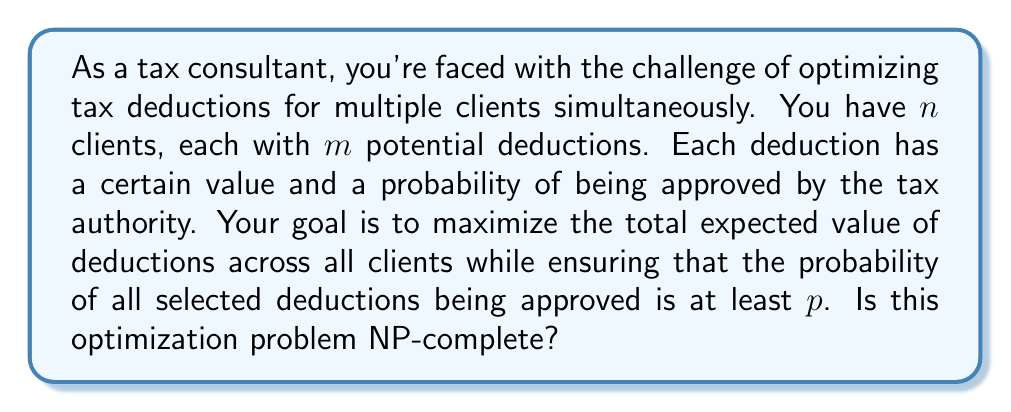What is the answer to this math problem? To determine if this problem is NP-complete, we need to show that it is both in NP and NP-hard.

1. The problem is in NP:
   A solution can be verified in polynomial time by calculating the total expected value of the selected deductions and checking if the probability of all being approved is at least $p$.

2. To prove NP-hardness, we can reduce a known NP-complete problem to this one. Let's reduce the 0-1 Knapsack problem to our tax deduction optimization problem.

   Reduction from 0-1 Knapsack:
   - For each item in the Knapsack problem, create a client with one deduction.
   - Set the value of each deduction to the value of the corresponding Knapsack item.
   - Set the weight of each Knapsack item as $w_i = -\log(p_i)$, where $p_i$ is the probability of the deduction being approved.
   - Set the Knapsack capacity $W = -\log(p)$, where $p$ is the minimum probability of all deductions being approved.

   This reduction preserves the structure of the problem:
   $$\prod_{i=1}^n p_i \geq p \iff \sum_{i=1}^n -\log(p_i) \leq -\log(p)$$

   The reduction is polynomial-time computable, and a solution to the tax deduction problem would solve the 0-1 Knapsack problem.

3. The decision version of this problem ("Is there a selection of deductions with total expected value at least $V$ and probability of all being approved at least $p$?") is in NP and NP-hard, making it NP-complete.

4. The optimization version, which asks for the maximum total expected value, is at least as hard as the decision version. Therefore, it is NP-hard.
Answer: Yes, the problem of optimizing tax deductions for multiple clients simultaneously, as described, is NP-complete in its decision version and NP-hard in its optimization version. 